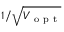<formula> <loc_0><loc_0><loc_500><loc_500>1 / \sqrt { V _ { o p t } }</formula> 